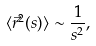Convert formula to latex. <formula><loc_0><loc_0><loc_500><loc_500>\langle \vec { r } ^ { 2 } ( s ) \rangle \sim \frac { 1 } { s ^ { 2 } } ,</formula> 